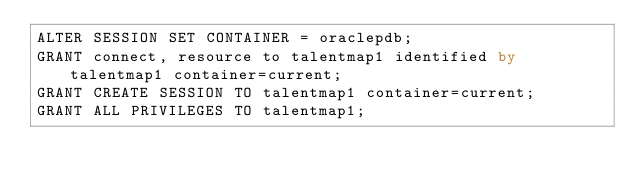Convert code to text. <code><loc_0><loc_0><loc_500><loc_500><_SQL_>ALTER SESSION SET CONTAINER = oraclepdb;
GRANT connect, resource to talentmap1 identified by talentmap1 container=current;
GRANT CREATE SESSION TO talentmap1 container=current;
GRANT ALL PRIVILEGES TO talentmap1;
</code> 